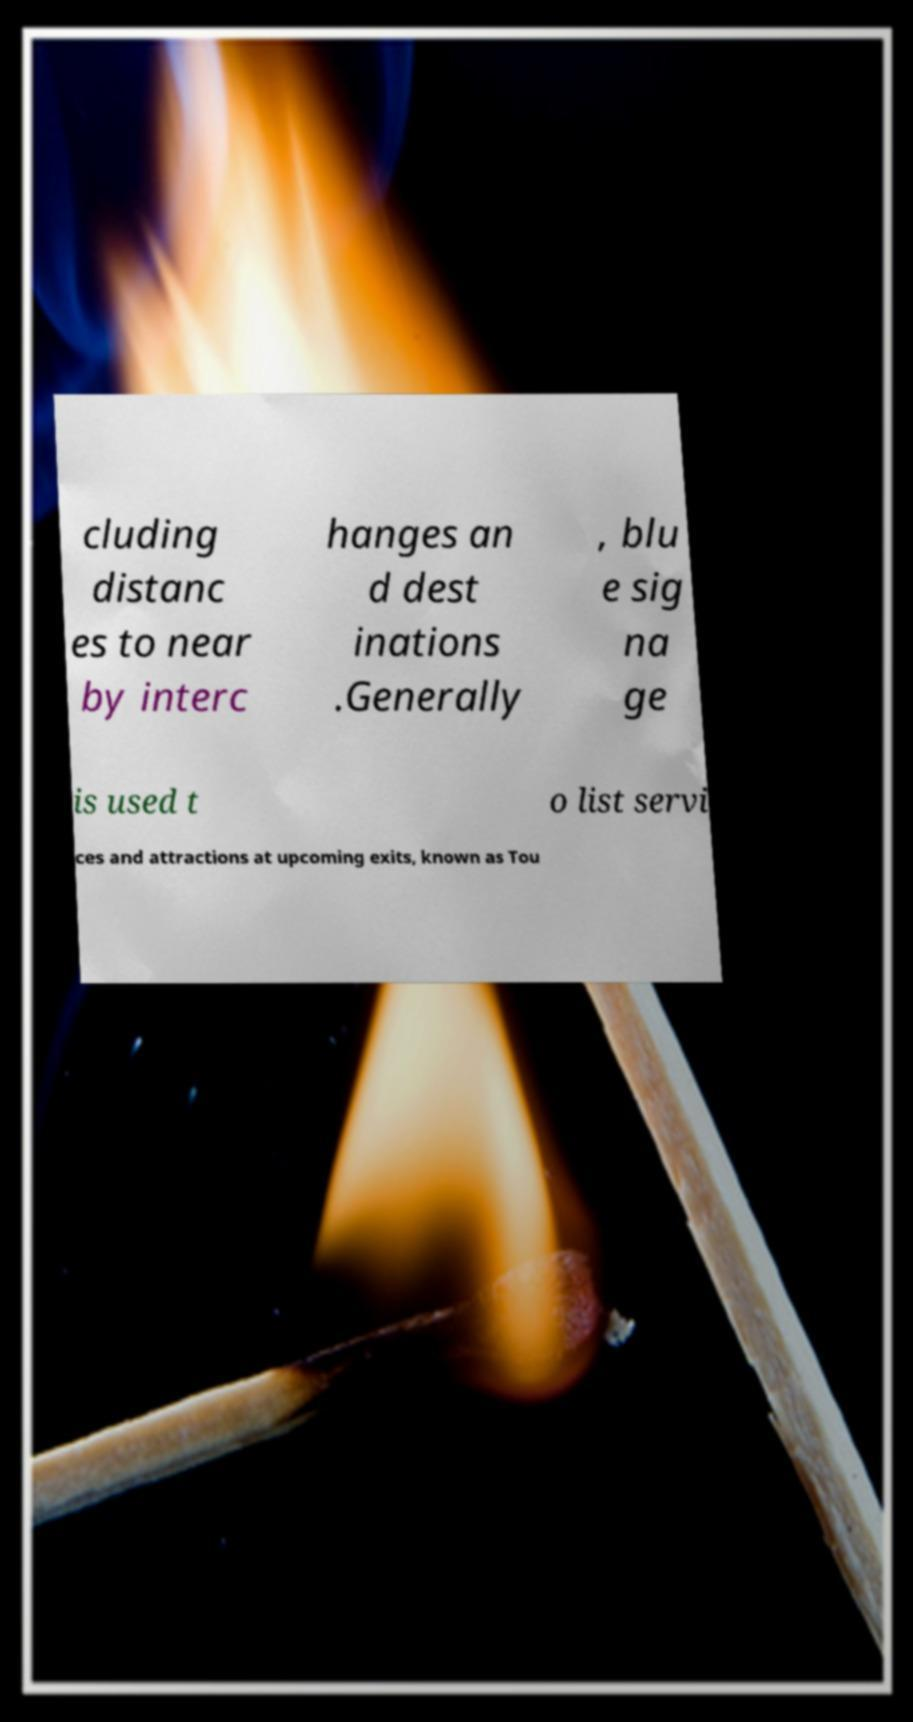There's text embedded in this image that I need extracted. Can you transcribe it verbatim? cluding distanc es to near by interc hanges an d dest inations .Generally , blu e sig na ge is used t o list servi ces and attractions at upcoming exits, known as Tou 